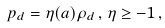<formula> <loc_0><loc_0><loc_500><loc_500>p _ { d } = \eta ( a ) \rho _ { d } \, , \, \eta \geq - 1 \, ,</formula> 